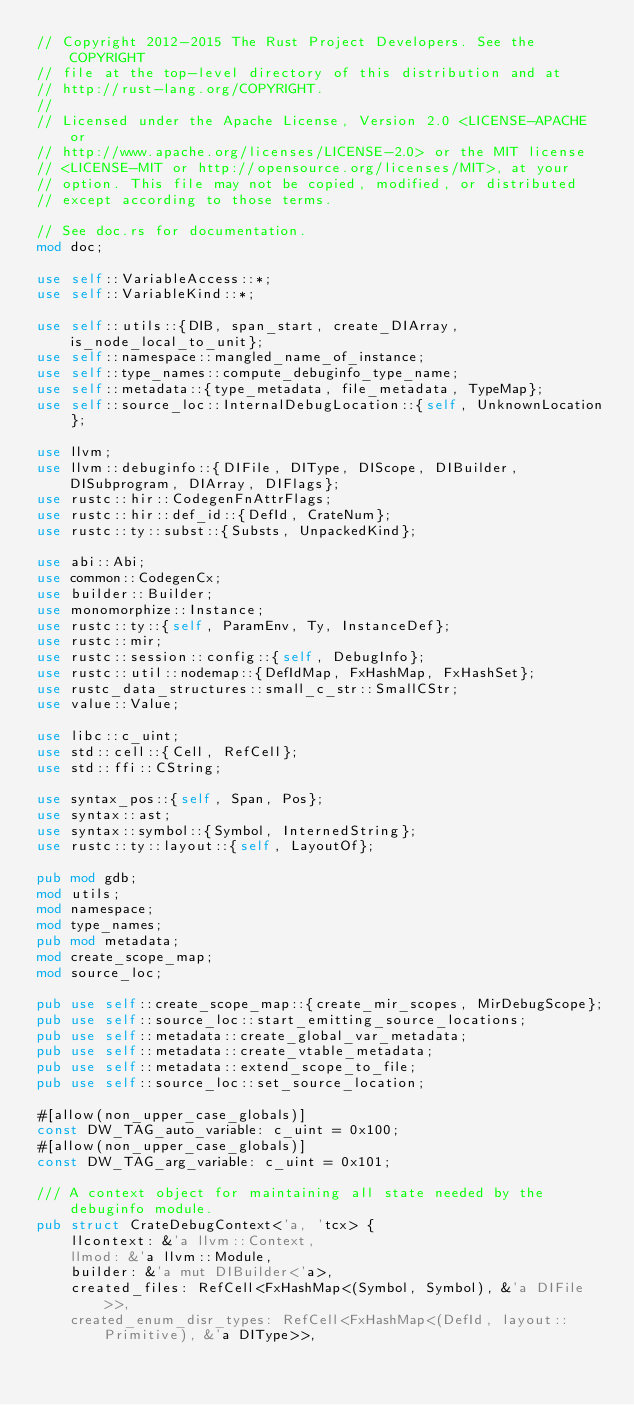<code> <loc_0><loc_0><loc_500><loc_500><_Rust_>// Copyright 2012-2015 The Rust Project Developers. See the COPYRIGHT
// file at the top-level directory of this distribution and at
// http://rust-lang.org/COPYRIGHT.
//
// Licensed under the Apache License, Version 2.0 <LICENSE-APACHE or
// http://www.apache.org/licenses/LICENSE-2.0> or the MIT license
// <LICENSE-MIT or http://opensource.org/licenses/MIT>, at your
// option. This file may not be copied, modified, or distributed
// except according to those terms.

// See doc.rs for documentation.
mod doc;

use self::VariableAccess::*;
use self::VariableKind::*;

use self::utils::{DIB, span_start, create_DIArray, is_node_local_to_unit};
use self::namespace::mangled_name_of_instance;
use self::type_names::compute_debuginfo_type_name;
use self::metadata::{type_metadata, file_metadata, TypeMap};
use self::source_loc::InternalDebugLocation::{self, UnknownLocation};

use llvm;
use llvm::debuginfo::{DIFile, DIType, DIScope, DIBuilder, DISubprogram, DIArray, DIFlags};
use rustc::hir::CodegenFnAttrFlags;
use rustc::hir::def_id::{DefId, CrateNum};
use rustc::ty::subst::{Substs, UnpackedKind};

use abi::Abi;
use common::CodegenCx;
use builder::Builder;
use monomorphize::Instance;
use rustc::ty::{self, ParamEnv, Ty, InstanceDef};
use rustc::mir;
use rustc::session::config::{self, DebugInfo};
use rustc::util::nodemap::{DefIdMap, FxHashMap, FxHashSet};
use rustc_data_structures::small_c_str::SmallCStr;
use value::Value;

use libc::c_uint;
use std::cell::{Cell, RefCell};
use std::ffi::CString;

use syntax_pos::{self, Span, Pos};
use syntax::ast;
use syntax::symbol::{Symbol, InternedString};
use rustc::ty::layout::{self, LayoutOf};

pub mod gdb;
mod utils;
mod namespace;
mod type_names;
pub mod metadata;
mod create_scope_map;
mod source_loc;

pub use self::create_scope_map::{create_mir_scopes, MirDebugScope};
pub use self::source_loc::start_emitting_source_locations;
pub use self::metadata::create_global_var_metadata;
pub use self::metadata::create_vtable_metadata;
pub use self::metadata::extend_scope_to_file;
pub use self::source_loc::set_source_location;

#[allow(non_upper_case_globals)]
const DW_TAG_auto_variable: c_uint = 0x100;
#[allow(non_upper_case_globals)]
const DW_TAG_arg_variable: c_uint = 0x101;

/// A context object for maintaining all state needed by the debuginfo module.
pub struct CrateDebugContext<'a, 'tcx> {
    llcontext: &'a llvm::Context,
    llmod: &'a llvm::Module,
    builder: &'a mut DIBuilder<'a>,
    created_files: RefCell<FxHashMap<(Symbol, Symbol), &'a DIFile>>,
    created_enum_disr_types: RefCell<FxHashMap<(DefId, layout::Primitive), &'a DIType>>,
</code> 